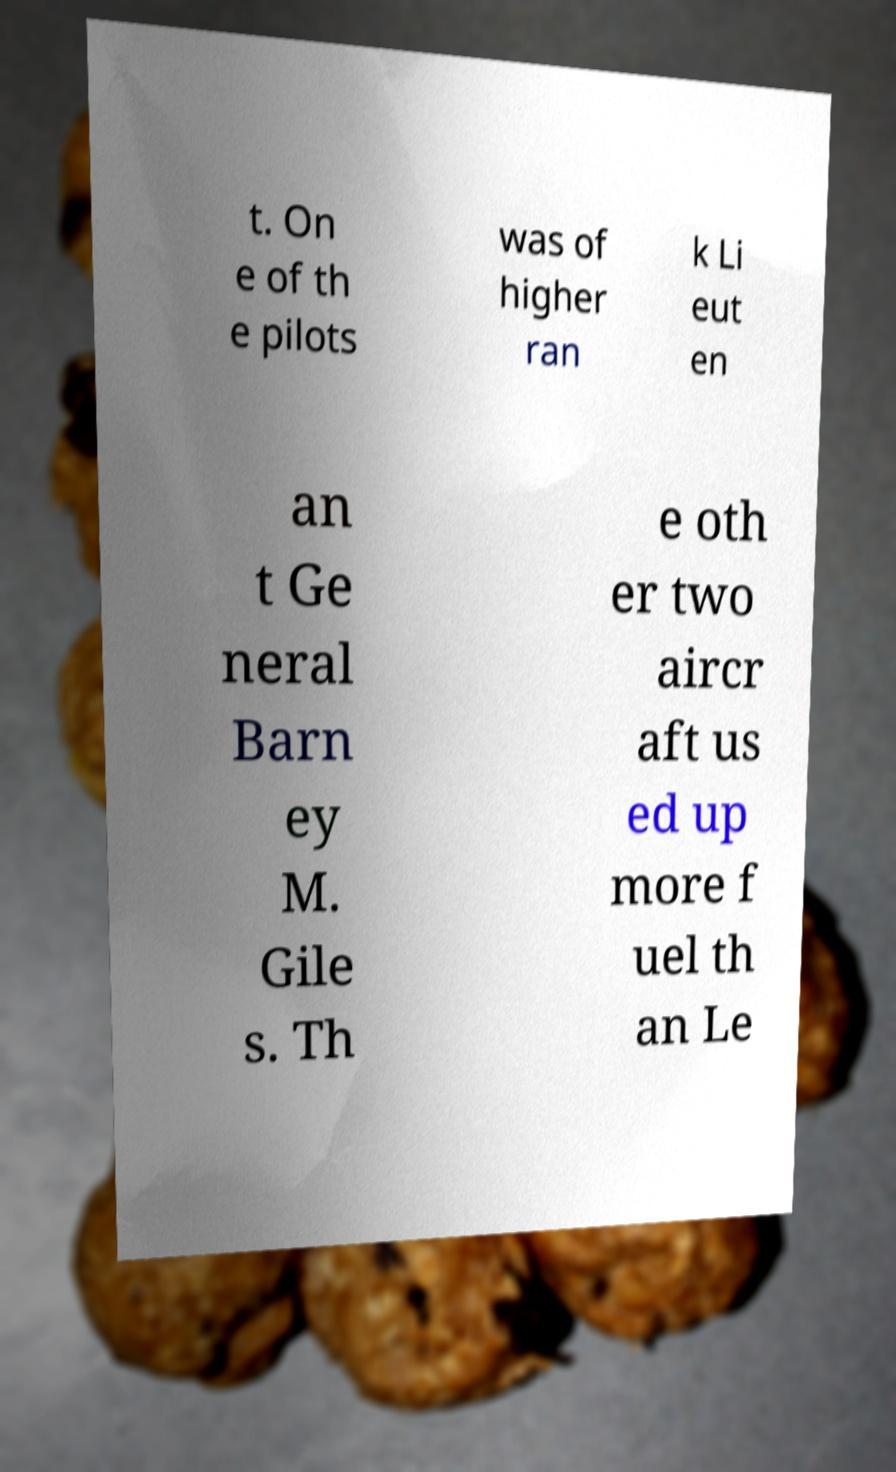Please read and relay the text visible in this image. What does it say? t. On e of th e pilots was of higher ran k Li eut en an t Ge neral Barn ey M. Gile s. Th e oth er two aircr aft us ed up more f uel th an Le 